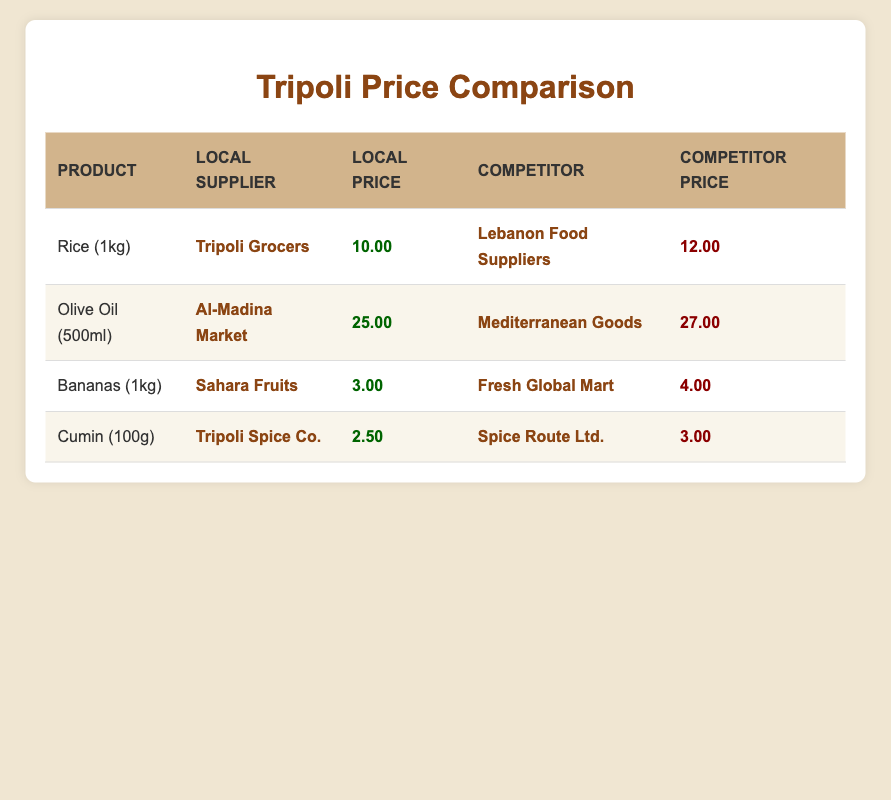What is the price of rice from Tripoli Grocers? According to the table, Tripoli Grocers offers rice at a price of 10.00.
Answer: 10.00 Which local supplier has the highest price for olive oil? Al-Madina Market sells olive oil for 25.00, which is higher than Mediterranean Goods' price of 27.00, making it the highest local supplier for olive oil prices.
Answer: Al-Madina Market What is the price difference between bananas at Sahara Fruits and Fresh Global Mart? Sahara Fruits sells bananas for 3.00 and Fresh Global Mart sells them for 4.00. To find the price difference, subtract 3.00 from 4.00: 4.00 - 3.00 = 1.00.
Answer: 1.00 Is the price of cumin at Tripoli Spice Co. lower than at Spice Route Ltd.? Tripoli Spice Co. sells cumin for 2.50 while Spice Route Ltd. sells it for 3.00. Since 2.50 is less than 3.00, the price at Tripoli Spice Co. is indeed lower.
Answer: Yes What is the average price of rice, olive oil, and cumin from local suppliers? The prices from local suppliers are: Rice (10.00), Olive Oil (25.00), and Cumin (2.50). First, sum these prices: 10.00 + 25.00 + 2.50 = 37.50. There are 3 products, so the average price is 37.50 divided by 3, which equals 12.50.
Answer: 12.50 